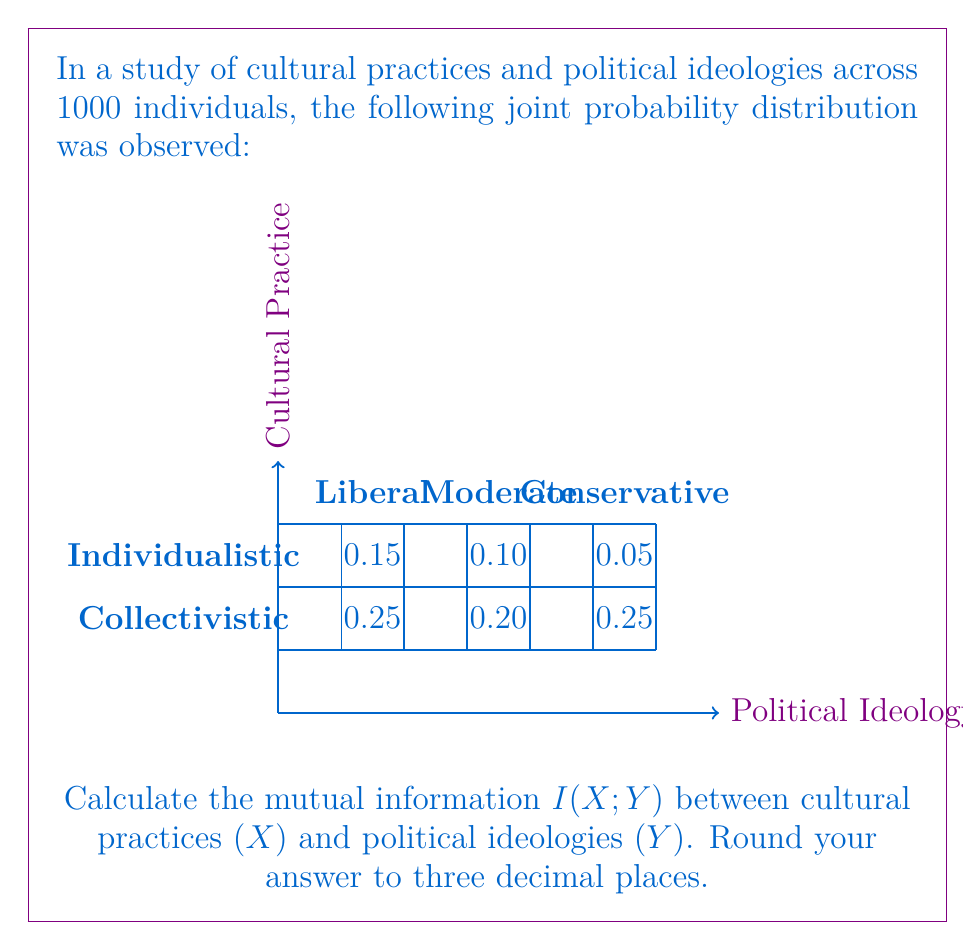Show me your answer to this math problem. To calculate the mutual information $I(X;Y)$, we'll follow these steps:

1) First, calculate the marginal probabilities:
   $P(X = \text{Individualistic}) = 0.15 + 0.10 + 0.05 = 0.30$
   $P(X = \text{Collectivistic}) = 0.25 + 0.20 + 0.25 = 0.70$
   $P(Y = \text{Liberal}) = 0.15 + 0.25 = 0.40$
   $P(Y = \text{Moderate}) = 0.10 + 0.20 = 0.30$
   $P(Y = \text{Conservative}) = 0.05 + 0.25 = 0.30$

2) The mutual information is given by:
   $I(X;Y) = \sum_{x \in X} \sum_{y \in Y} P(x,y) \log_2 \frac{P(x,y)}{P(x)P(y)}$

3) Calculate each term:
   $0.15 \log_2 \frac{0.15}{0.30 \cdot 0.40} = 0.15 \log_2 1.25 = 0.0361$
   $0.10 \log_2 \frac{0.10}{0.30 \cdot 0.30} = 0.10 \log_2 1.11 = 0.0152$
   $0.05 \log_2 \frac{0.05}{0.30 \cdot 0.30} = 0.05 \log_2 0.56 = -0.0415$
   $0.25 \log_2 \frac{0.25}{0.70 \cdot 0.40} = 0.25 \log_2 0.89 = -0.0308$
   $0.20 \log_2 \frac{0.20}{0.70 \cdot 0.30} = 0.20 \log_2 0.95 = -0.0103$
   $0.25 \log_2 \frac{0.25}{0.70 \cdot 0.30} = 0.25 \log_2 1.19 = 0.0422$

4) Sum all terms:
   $I(X;Y) = 0.0361 + 0.0152 - 0.0415 - 0.0308 - 0.0103 + 0.0422 = 0.0109$

5) Round to three decimal places: 0.011 bits
Answer: 0.011 bits 